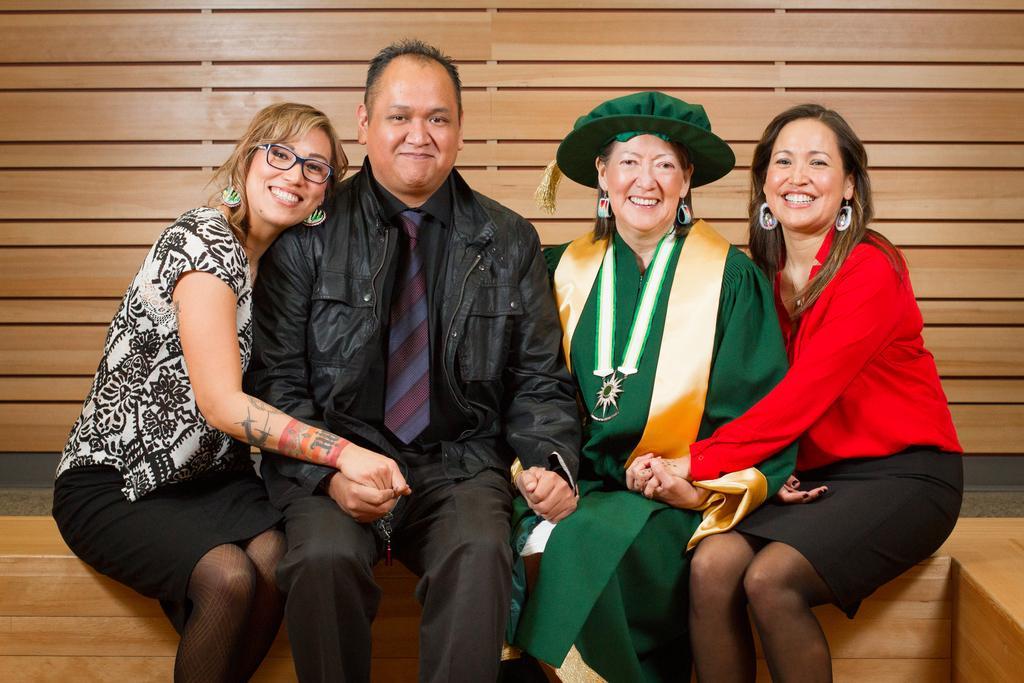In one or two sentences, can you explain what this image depicts? In the image there is a man,woman and two ladies sitting on wooden bench in front of wooden wall. 